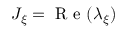Convert formula to latex. <formula><loc_0><loc_0><loc_500><loc_500>J _ { \xi } = R e ( \lambda _ { \xi } )</formula> 